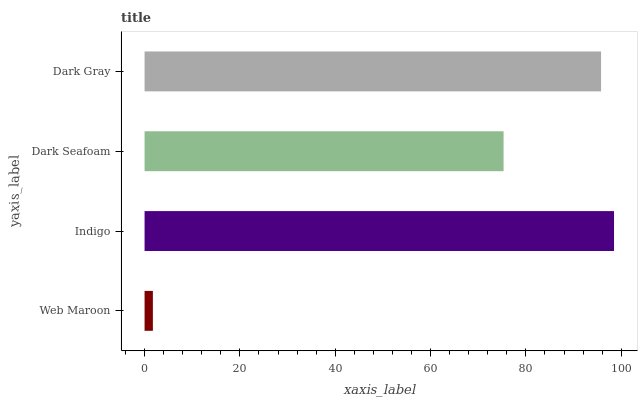Is Web Maroon the minimum?
Answer yes or no. Yes. Is Indigo the maximum?
Answer yes or no. Yes. Is Dark Seafoam the minimum?
Answer yes or no. No. Is Dark Seafoam the maximum?
Answer yes or no. No. Is Indigo greater than Dark Seafoam?
Answer yes or no. Yes. Is Dark Seafoam less than Indigo?
Answer yes or no. Yes. Is Dark Seafoam greater than Indigo?
Answer yes or no. No. Is Indigo less than Dark Seafoam?
Answer yes or no. No. Is Dark Gray the high median?
Answer yes or no. Yes. Is Dark Seafoam the low median?
Answer yes or no. Yes. Is Dark Seafoam the high median?
Answer yes or no. No. Is Dark Gray the low median?
Answer yes or no. No. 